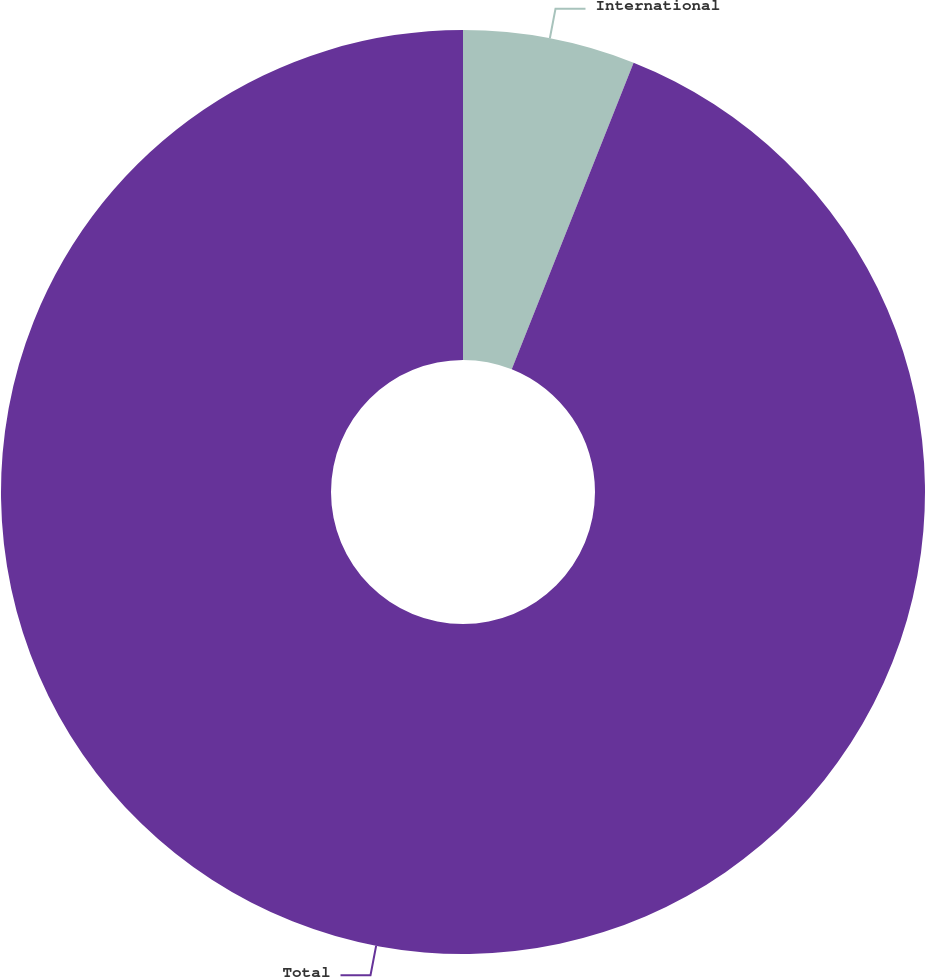Convert chart to OTSL. <chart><loc_0><loc_0><loc_500><loc_500><pie_chart><fcel>International<fcel>Total<nl><fcel>6.02%<fcel>93.98%<nl></chart> 